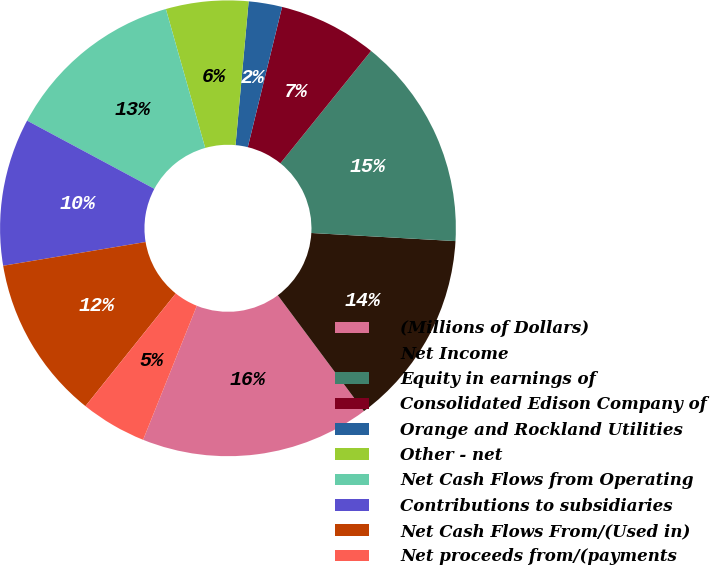Convert chart to OTSL. <chart><loc_0><loc_0><loc_500><loc_500><pie_chart><fcel>(Millions of Dollars)<fcel>Net Income<fcel>Equity in earnings of<fcel>Consolidated Edison Company of<fcel>Orange and Rockland Utilities<fcel>Other - net<fcel>Net Cash Flows from Operating<fcel>Contributions to subsidiaries<fcel>Net Cash Flows From/(Used in)<fcel>Net proceeds from/(payments<nl><fcel>16.25%<fcel>13.93%<fcel>15.09%<fcel>6.99%<fcel>2.37%<fcel>5.84%<fcel>12.78%<fcel>10.46%<fcel>11.62%<fcel>4.68%<nl></chart> 